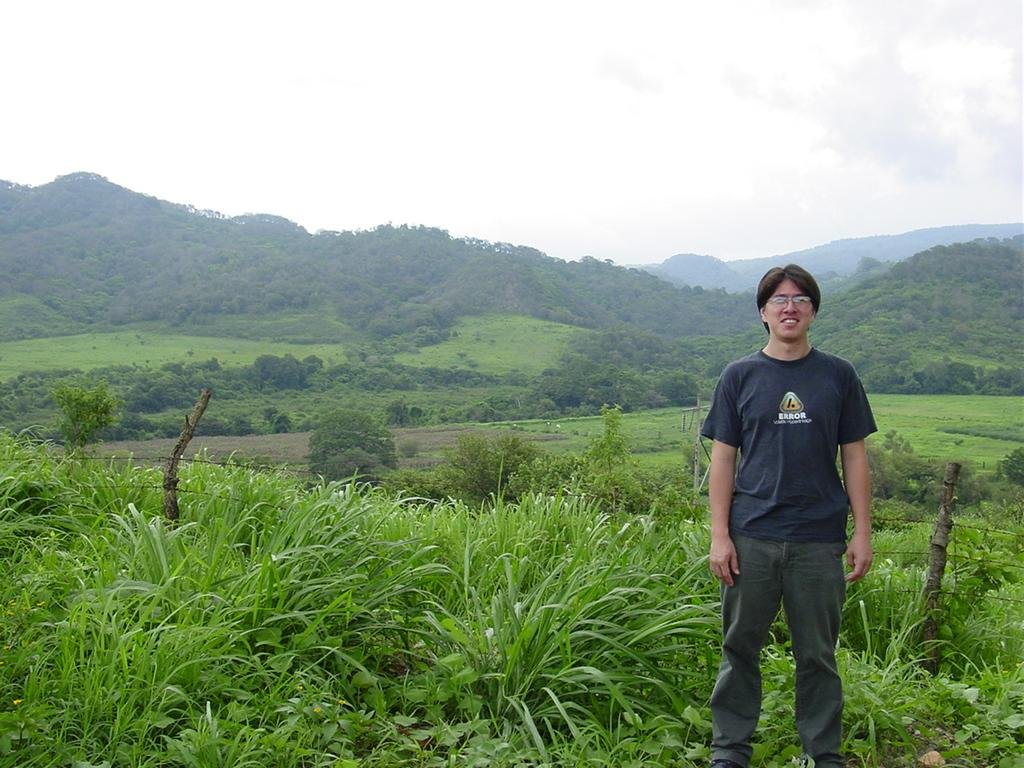What is the position of the person in the image? There is a person standing on the right side of the image. What can be seen from left to right in the image? There are plants visible from left to right in the image. What type of vegetation is in the background of the image? There are trees in the background of the image. What is the condition of the sky in the image? The sky is cloudy in the image. What is the name of the square where the person is standing in the image? There is no square mentioned in the image, and the person is standing on the right side of the image, not in a square. Is the person eating popcorn while standing in the image? There is no indication of popcorn or any food in the image. 